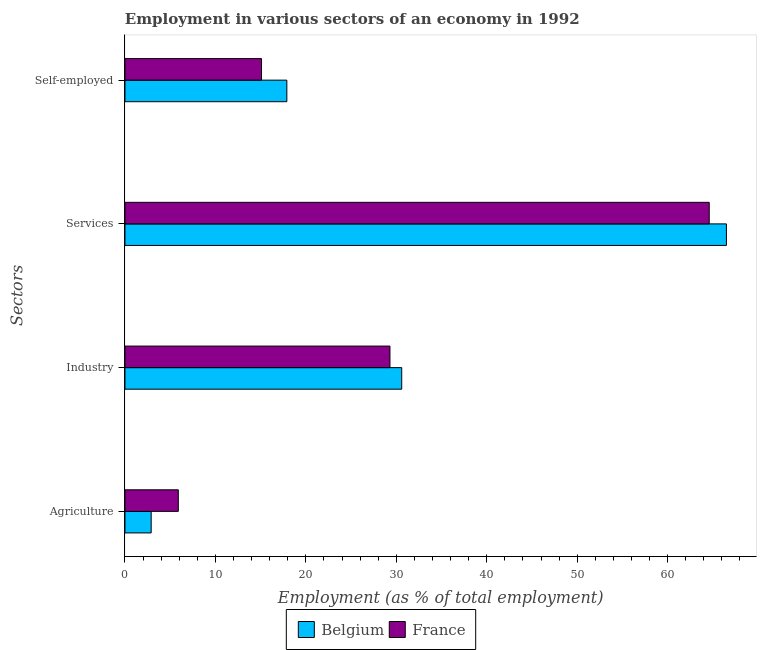How many different coloured bars are there?
Offer a terse response. 2. How many groups of bars are there?
Offer a terse response. 4. Are the number of bars per tick equal to the number of legend labels?
Provide a short and direct response. Yes. How many bars are there on the 2nd tick from the top?
Your answer should be compact. 2. What is the label of the 2nd group of bars from the top?
Make the answer very short. Services. What is the percentage of self employed workers in Belgium?
Your answer should be compact. 17.9. Across all countries, what is the maximum percentage of self employed workers?
Your answer should be very brief. 17.9. Across all countries, what is the minimum percentage of self employed workers?
Your answer should be compact. 15.1. In which country was the percentage of workers in industry maximum?
Keep it short and to the point. Belgium. In which country was the percentage of workers in industry minimum?
Your answer should be very brief. France. What is the total percentage of workers in agriculture in the graph?
Provide a succinct answer. 8.8. What is the difference between the percentage of workers in industry in Belgium and that in France?
Ensure brevity in your answer.  1.3. What is the difference between the percentage of workers in services in Belgium and the percentage of workers in agriculture in France?
Keep it short and to the point. 60.6. What is the average percentage of workers in services per country?
Make the answer very short. 65.55. What is the difference between the percentage of workers in services and percentage of workers in agriculture in Belgium?
Provide a succinct answer. 63.6. In how many countries, is the percentage of workers in industry greater than 26 %?
Provide a succinct answer. 2. What is the ratio of the percentage of self employed workers in France to that in Belgium?
Your answer should be very brief. 0.84. Is the percentage of workers in agriculture in France less than that in Belgium?
Keep it short and to the point. No. Is the difference between the percentage of workers in industry in Belgium and France greater than the difference between the percentage of workers in agriculture in Belgium and France?
Provide a short and direct response. Yes. What is the difference between the highest and the second highest percentage of workers in agriculture?
Ensure brevity in your answer.  3. What is the difference between the highest and the lowest percentage of workers in industry?
Your answer should be very brief. 1.3. What does the 1st bar from the bottom in Industry represents?
Offer a terse response. Belgium. Are all the bars in the graph horizontal?
Offer a very short reply. Yes. How many countries are there in the graph?
Ensure brevity in your answer.  2. Does the graph contain any zero values?
Ensure brevity in your answer.  No. How are the legend labels stacked?
Offer a very short reply. Horizontal. What is the title of the graph?
Offer a very short reply. Employment in various sectors of an economy in 1992. Does "Canada" appear as one of the legend labels in the graph?
Offer a terse response. No. What is the label or title of the X-axis?
Give a very brief answer. Employment (as % of total employment). What is the label or title of the Y-axis?
Provide a short and direct response. Sectors. What is the Employment (as % of total employment) in Belgium in Agriculture?
Make the answer very short. 2.9. What is the Employment (as % of total employment) in France in Agriculture?
Offer a terse response. 5.9. What is the Employment (as % of total employment) in Belgium in Industry?
Offer a terse response. 30.6. What is the Employment (as % of total employment) of France in Industry?
Offer a terse response. 29.3. What is the Employment (as % of total employment) of Belgium in Services?
Make the answer very short. 66.5. What is the Employment (as % of total employment) of France in Services?
Ensure brevity in your answer.  64.6. What is the Employment (as % of total employment) of Belgium in Self-employed?
Keep it short and to the point. 17.9. What is the Employment (as % of total employment) of France in Self-employed?
Your answer should be very brief. 15.1. Across all Sectors, what is the maximum Employment (as % of total employment) of Belgium?
Provide a short and direct response. 66.5. Across all Sectors, what is the maximum Employment (as % of total employment) of France?
Give a very brief answer. 64.6. Across all Sectors, what is the minimum Employment (as % of total employment) of Belgium?
Offer a very short reply. 2.9. Across all Sectors, what is the minimum Employment (as % of total employment) in France?
Your answer should be compact. 5.9. What is the total Employment (as % of total employment) in Belgium in the graph?
Your answer should be compact. 117.9. What is the total Employment (as % of total employment) of France in the graph?
Your response must be concise. 114.9. What is the difference between the Employment (as % of total employment) in Belgium in Agriculture and that in Industry?
Offer a terse response. -27.7. What is the difference between the Employment (as % of total employment) in France in Agriculture and that in Industry?
Offer a terse response. -23.4. What is the difference between the Employment (as % of total employment) in Belgium in Agriculture and that in Services?
Make the answer very short. -63.6. What is the difference between the Employment (as % of total employment) in France in Agriculture and that in Services?
Make the answer very short. -58.7. What is the difference between the Employment (as % of total employment) in France in Agriculture and that in Self-employed?
Your response must be concise. -9.2. What is the difference between the Employment (as % of total employment) in Belgium in Industry and that in Services?
Your answer should be compact. -35.9. What is the difference between the Employment (as % of total employment) of France in Industry and that in Services?
Provide a succinct answer. -35.3. What is the difference between the Employment (as % of total employment) in Belgium in Industry and that in Self-employed?
Make the answer very short. 12.7. What is the difference between the Employment (as % of total employment) in Belgium in Services and that in Self-employed?
Ensure brevity in your answer.  48.6. What is the difference between the Employment (as % of total employment) in France in Services and that in Self-employed?
Provide a short and direct response. 49.5. What is the difference between the Employment (as % of total employment) in Belgium in Agriculture and the Employment (as % of total employment) in France in Industry?
Your answer should be compact. -26.4. What is the difference between the Employment (as % of total employment) in Belgium in Agriculture and the Employment (as % of total employment) in France in Services?
Provide a succinct answer. -61.7. What is the difference between the Employment (as % of total employment) of Belgium in Industry and the Employment (as % of total employment) of France in Services?
Make the answer very short. -34. What is the difference between the Employment (as % of total employment) of Belgium in Services and the Employment (as % of total employment) of France in Self-employed?
Offer a very short reply. 51.4. What is the average Employment (as % of total employment) of Belgium per Sectors?
Give a very brief answer. 29.48. What is the average Employment (as % of total employment) of France per Sectors?
Ensure brevity in your answer.  28.73. What is the ratio of the Employment (as % of total employment) in Belgium in Agriculture to that in Industry?
Offer a terse response. 0.09. What is the ratio of the Employment (as % of total employment) of France in Agriculture to that in Industry?
Offer a very short reply. 0.2. What is the ratio of the Employment (as % of total employment) in Belgium in Agriculture to that in Services?
Ensure brevity in your answer.  0.04. What is the ratio of the Employment (as % of total employment) in France in Agriculture to that in Services?
Keep it short and to the point. 0.09. What is the ratio of the Employment (as % of total employment) of Belgium in Agriculture to that in Self-employed?
Offer a terse response. 0.16. What is the ratio of the Employment (as % of total employment) in France in Agriculture to that in Self-employed?
Ensure brevity in your answer.  0.39. What is the ratio of the Employment (as % of total employment) of Belgium in Industry to that in Services?
Provide a short and direct response. 0.46. What is the ratio of the Employment (as % of total employment) of France in Industry to that in Services?
Ensure brevity in your answer.  0.45. What is the ratio of the Employment (as % of total employment) of Belgium in Industry to that in Self-employed?
Offer a very short reply. 1.71. What is the ratio of the Employment (as % of total employment) of France in Industry to that in Self-employed?
Your answer should be compact. 1.94. What is the ratio of the Employment (as % of total employment) in Belgium in Services to that in Self-employed?
Offer a very short reply. 3.72. What is the ratio of the Employment (as % of total employment) of France in Services to that in Self-employed?
Your response must be concise. 4.28. What is the difference between the highest and the second highest Employment (as % of total employment) in Belgium?
Offer a terse response. 35.9. What is the difference between the highest and the second highest Employment (as % of total employment) of France?
Provide a succinct answer. 35.3. What is the difference between the highest and the lowest Employment (as % of total employment) of Belgium?
Give a very brief answer. 63.6. What is the difference between the highest and the lowest Employment (as % of total employment) in France?
Provide a short and direct response. 58.7. 